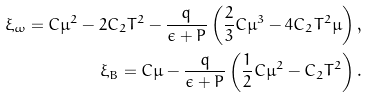<formula> <loc_0><loc_0><loc_500><loc_500>\xi _ { \omega } = C \mu ^ { 2 } - 2 C _ { 2 } T ^ { 2 } - \frac { q } { \epsilon + P } \left ( \frac { 2 } { 3 } C \mu ^ { 3 } - 4 C _ { 2 } T ^ { 2 } \mu \right ) , \\ \xi _ { B } = C \mu - \frac { q } { \epsilon + P } \left ( \frac { 1 } { 2 } C \mu ^ { 2 } - C _ { 2 } T ^ { 2 } \right ) .</formula> 